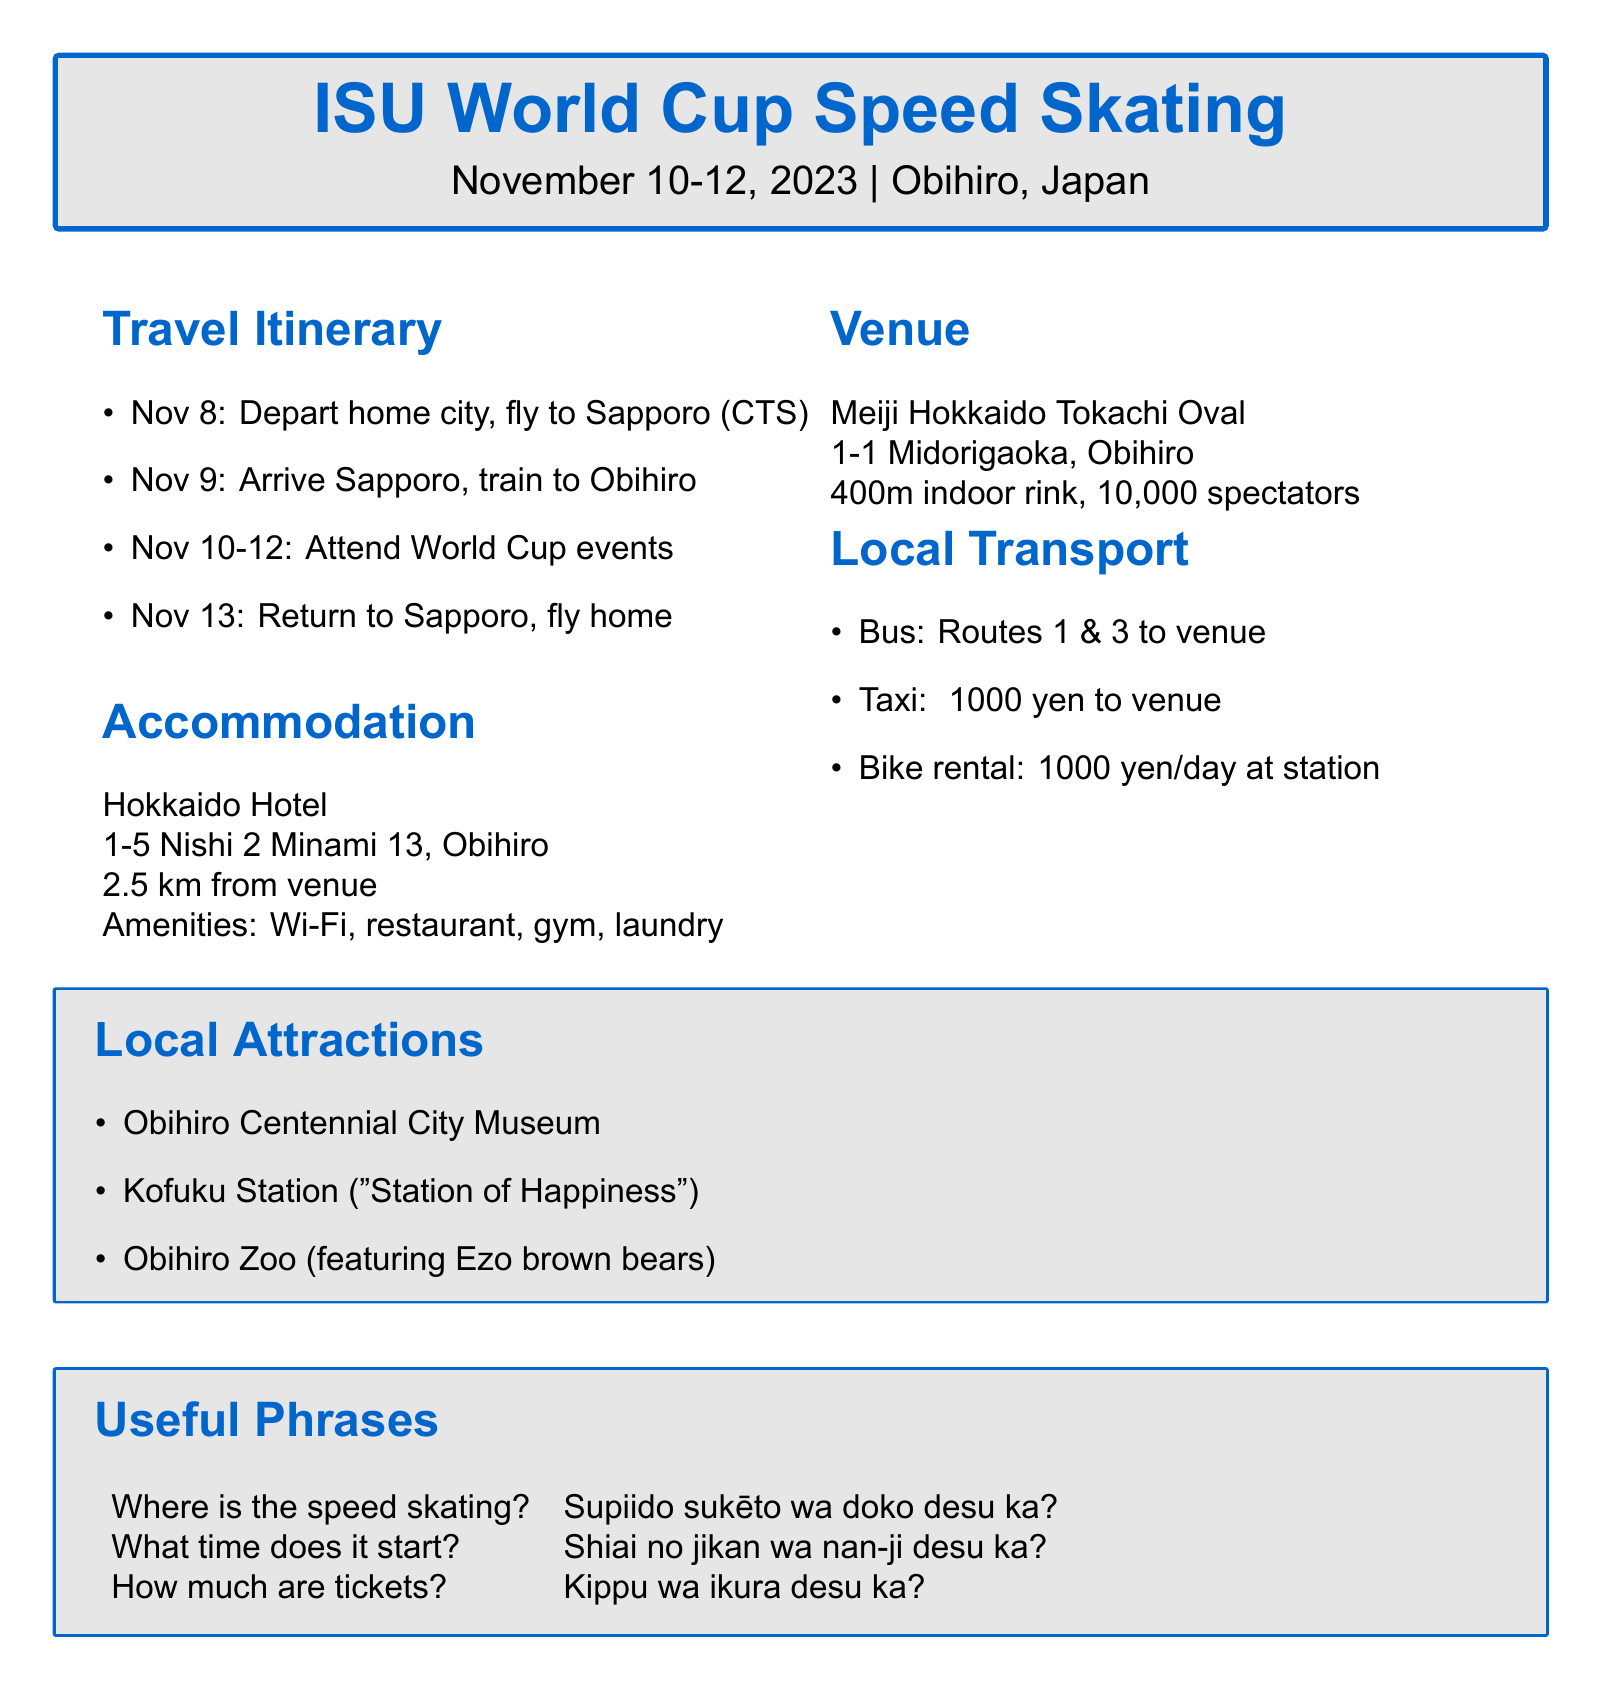What are the event dates? The event dates for the ISU World Cup Speed Skating are listed as November 10-12, 2023.
Answer: November 10-12, 2023 What is the name of the accommodation? The document provides the name of the hotel where participants will stay, which is Hokkaido Hotel.
Answer: Hokkaido Hotel What is the transportation method from Sapporo to Obihiro? The travel itinerary specifies the method of transportation as a JR Hokkaido Limited Express Train for this leg of the journey.
Answer: JR Hokkaido Limited Express Train What local transportation option costs approximately 1000 yen? The document mentions that taking a taxi from the hotel to the venue costs around 1000 yen.
Answer: 1000 yen How far is the accommodation from the venue? The distance to the venue from the hotel is stated as 2.5 km.
Answer: 2.5 km What is the capacity of the Meiji Hokkaido Tokachi Oval? The seating capacity for spectators at the competition venue is noted as 10,000 in the document.
Answer: 10,000 What language phrases are included in the document? The document provides useful Japanese phrases related to the event, including questions about speed skating and ticket prices.
Answer: Supiido sukēto wa doko desu ka? What is one of the local attractions mentioned? The document lists several local attractions, including the Obihiro Centennial City Museum as an example.
Answer: Obihiro Centennial City Museum 